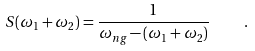<formula> <loc_0><loc_0><loc_500><loc_500>S ( \omega _ { 1 } + \omega _ { 2 } ) = \frac { 1 } { \omega _ { n g } - ( \omega _ { 1 } + \omega _ { 2 } ) } \quad .</formula> 